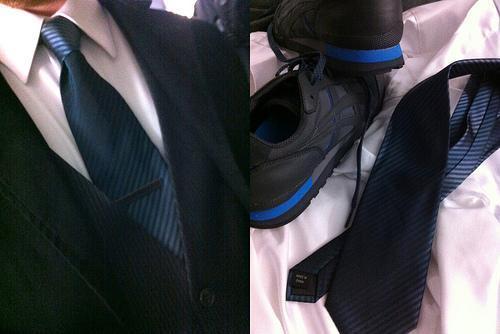How many ties are there?
Give a very brief answer. 2. 